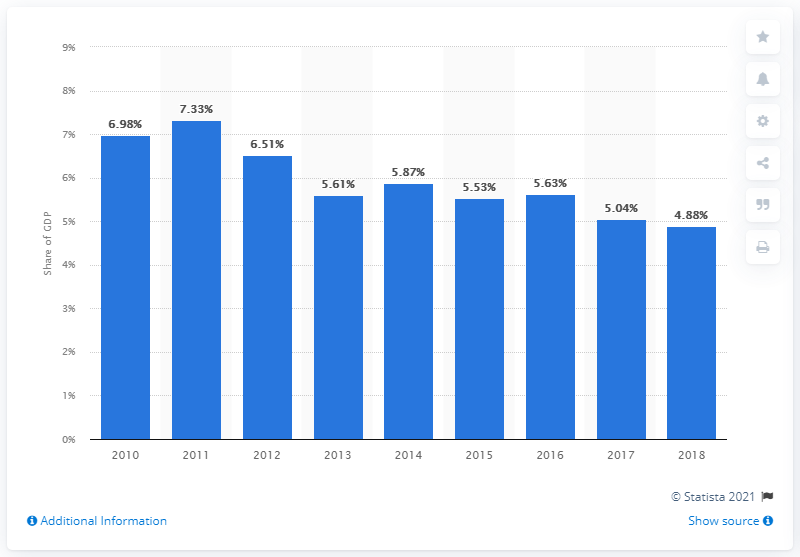Draw attention to some important aspects in this diagram. In 2018, El Salvador's agricultural sector contributed 4.88% of the total value added to the country's Gross Domestic Product (GDP). 